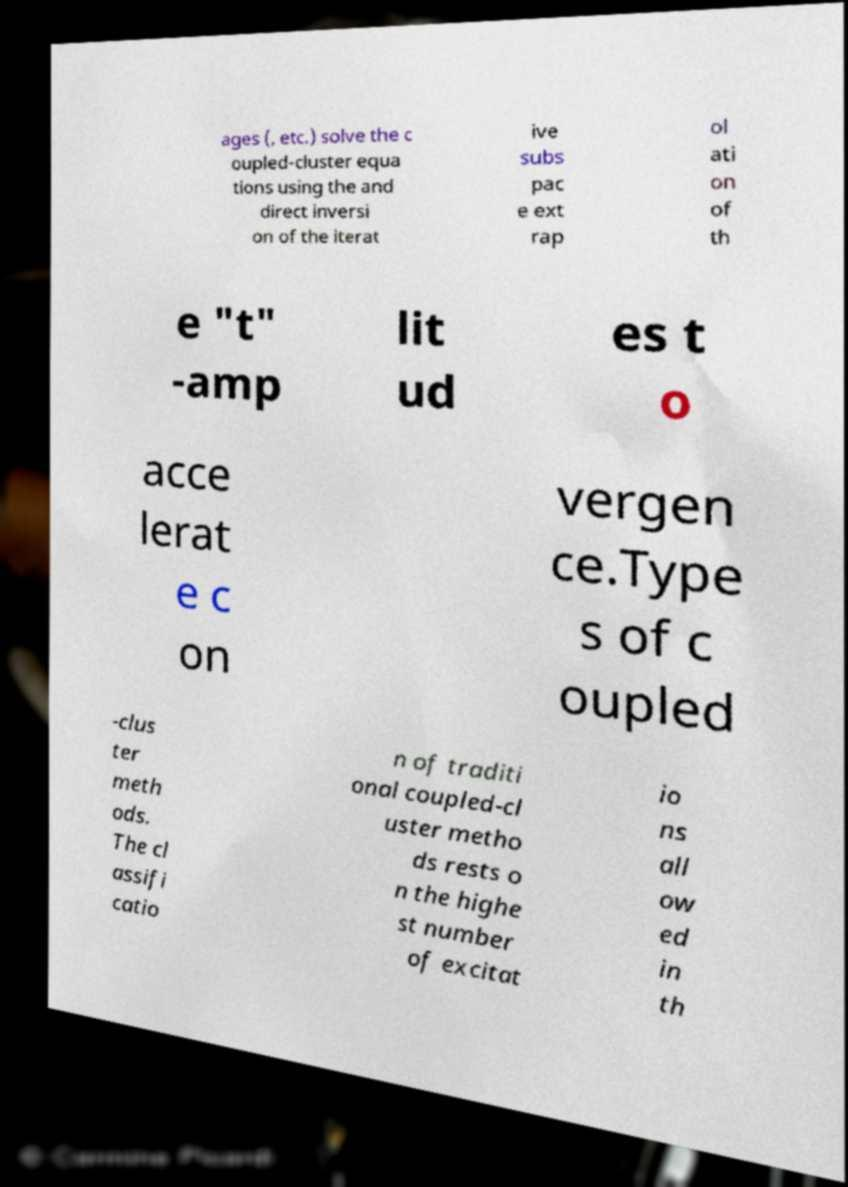Can you read and provide the text displayed in the image?This photo seems to have some interesting text. Can you extract and type it out for me? ages (, etc.) solve the c oupled-cluster equa tions using the and direct inversi on of the iterat ive subs pac e ext rap ol ati on of th e "t" -amp lit ud es t o acce lerat e c on vergen ce.Type s of c oupled -clus ter meth ods. The cl assifi catio n of traditi onal coupled-cl uster metho ds rests o n the highe st number of excitat io ns all ow ed in th 